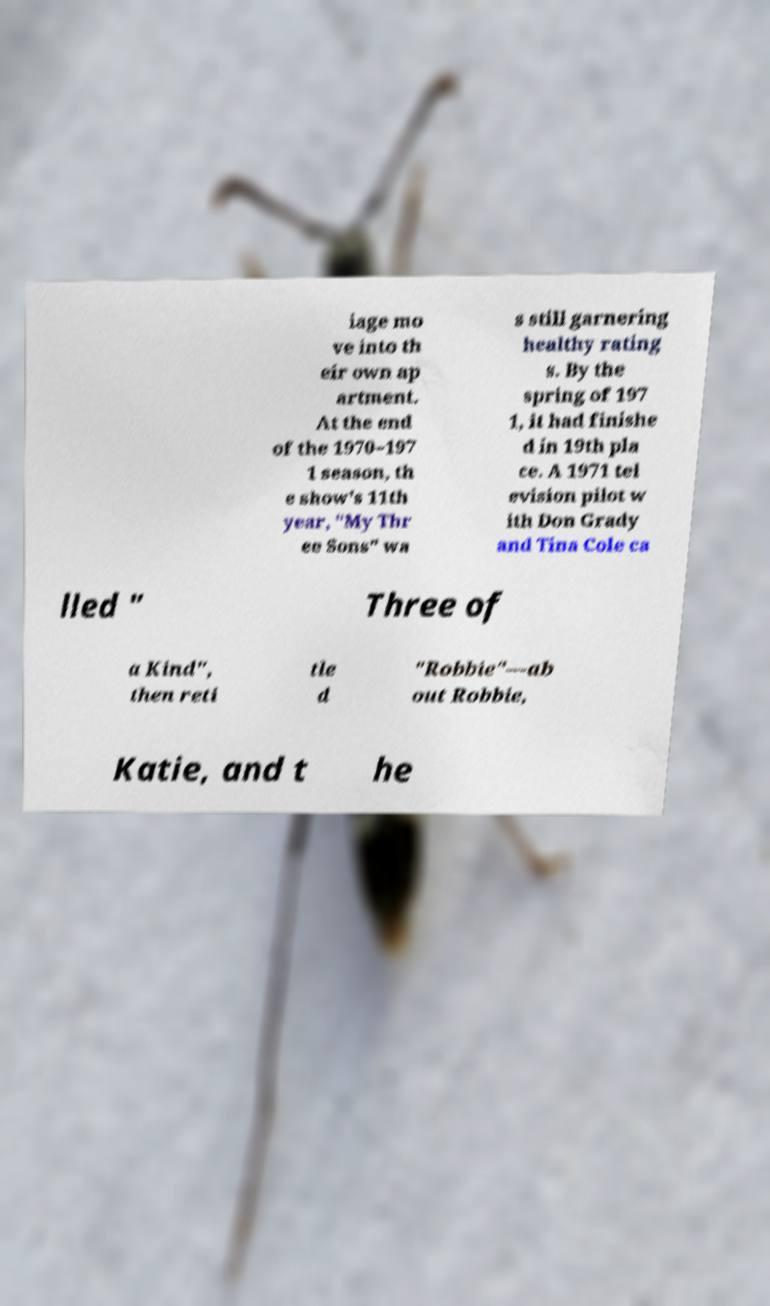Could you extract and type out the text from this image? iage mo ve into th eir own ap artment. At the end of the 1970–197 1 season, th e show's 11th year, "My Thr ee Sons" wa s still garnering healthy rating s. By the spring of 197 1, it had finishe d in 19th pla ce. A 1971 tel evision pilot w ith Don Grady and Tina Cole ca lled " Three of a Kind", then reti tle d "Robbie"—ab out Robbie, Katie, and t he 